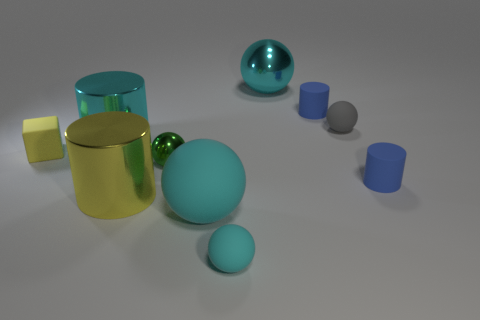Subtract all yellow cubes. How many cyan spheres are left? 3 Subtract 2 cylinders. How many cylinders are left? 2 Subtract all green balls. How many balls are left? 4 Subtract all tiny rubber balls. How many balls are left? 3 Subtract all gray cylinders. Subtract all green blocks. How many cylinders are left? 4 Subtract all blocks. How many objects are left? 9 Subtract 0 blue blocks. How many objects are left? 10 Subtract all small green shiny objects. Subtract all small blue rubber cylinders. How many objects are left? 7 Add 4 big cyan metallic spheres. How many big cyan metallic spheres are left? 5 Add 6 large yellow things. How many large yellow things exist? 7 